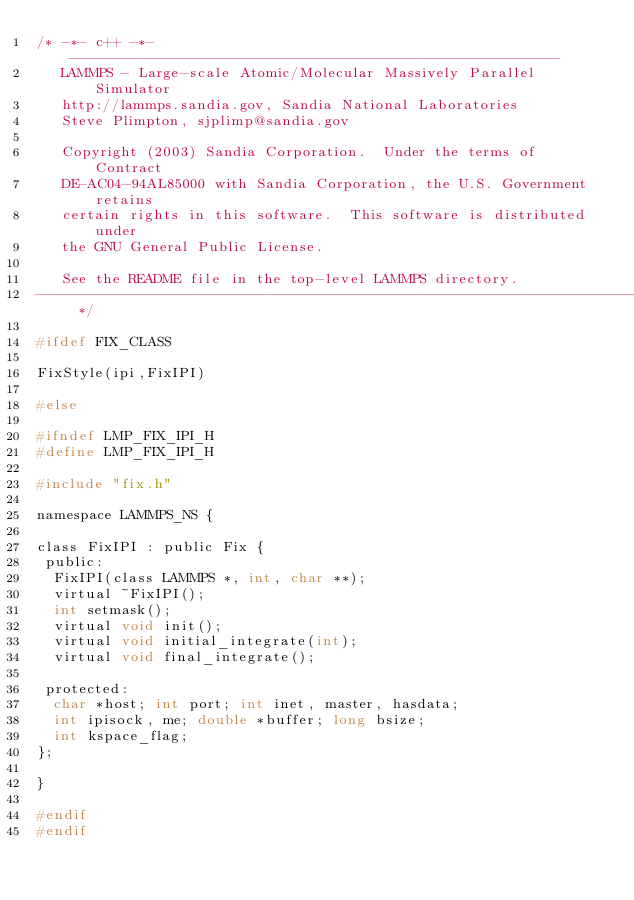Convert code to text. <code><loc_0><loc_0><loc_500><loc_500><_C_>/* -*- c++ -*- ----------------------------------------------------------
   LAMMPS - Large-scale Atomic/Molecular Massively Parallel Simulator
   http://lammps.sandia.gov, Sandia National Laboratories
   Steve Plimpton, sjplimp@sandia.gov

   Copyright (2003) Sandia Corporation.  Under the terms of Contract
   DE-AC04-94AL85000 with Sandia Corporation, the U.S. Government retains
   certain rights in this software.  This software is distributed under
   the GNU General Public License.

   See the README file in the top-level LAMMPS directory.
------------------------------------------------------------------------- */

#ifdef FIX_CLASS

FixStyle(ipi,FixIPI)

#else

#ifndef LMP_FIX_IPI_H
#define LMP_FIX_IPI_H

#include "fix.h"

namespace LAMMPS_NS {

class FixIPI : public Fix {
 public:
  FixIPI(class LAMMPS *, int, char **);
  virtual ~FixIPI();
  int setmask();
  virtual void init();
  virtual void initial_integrate(int);
  virtual void final_integrate();

 protected:
  char *host; int port; int inet, master, hasdata;
  int ipisock, me; double *buffer; long bsize;
  int kspace_flag;
};

}

#endif
#endif
</code> 